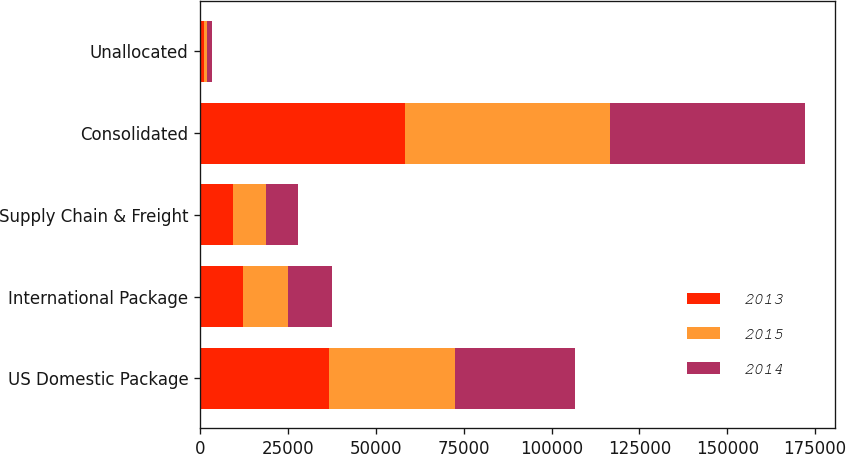<chart> <loc_0><loc_0><loc_500><loc_500><stacked_bar_chart><ecel><fcel>US Domestic Package<fcel>International Package<fcel>Supply Chain & Freight<fcel>Consolidated<fcel>Unallocated<nl><fcel>2013<fcel>36747<fcel>12149<fcel>9467<fcel>58363<fcel>1024<nl><fcel>2015<fcel>35851<fcel>12988<fcel>9393<fcel>58232<fcel>878<nl><fcel>2014<fcel>34074<fcel>12429<fcel>8935<fcel>55438<fcel>1477<nl></chart> 